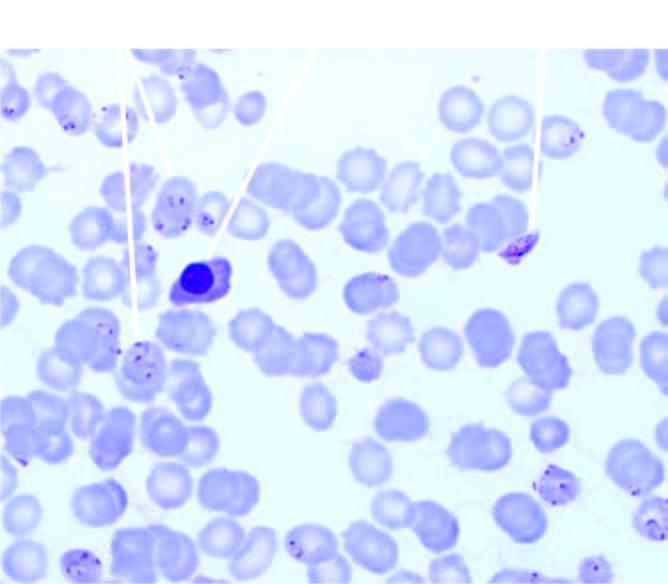does the background show a normoblast?
Answer the question using a single word or phrase. Yes 